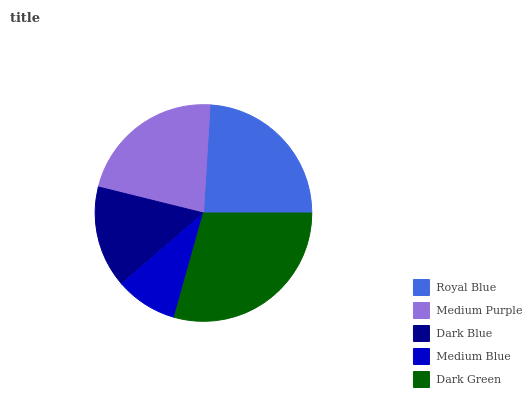Is Medium Blue the minimum?
Answer yes or no. Yes. Is Dark Green the maximum?
Answer yes or no. Yes. Is Medium Purple the minimum?
Answer yes or no. No. Is Medium Purple the maximum?
Answer yes or no. No. Is Royal Blue greater than Medium Purple?
Answer yes or no. Yes. Is Medium Purple less than Royal Blue?
Answer yes or no. Yes. Is Medium Purple greater than Royal Blue?
Answer yes or no. No. Is Royal Blue less than Medium Purple?
Answer yes or no. No. Is Medium Purple the high median?
Answer yes or no. Yes. Is Medium Purple the low median?
Answer yes or no. Yes. Is Medium Blue the high median?
Answer yes or no. No. Is Medium Blue the low median?
Answer yes or no. No. 